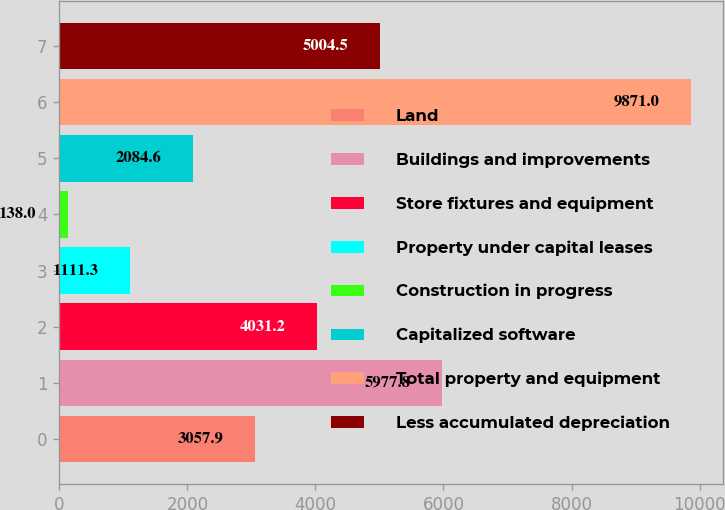Convert chart to OTSL. <chart><loc_0><loc_0><loc_500><loc_500><bar_chart><fcel>Land<fcel>Buildings and improvements<fcel>Store fixtures and equipment<fcel>Property under capital leases<fcel>Construction in progress<fcel>Capitalized software<fcel>Total property and equipment<fcel>Less accumulated depreciation<nl><fcel>3057.9<fcel>5977.8<fcel>4031.2<fcel>1111.3<fcel>138<fcel>2084.6<fcel>9871<fcel>5004.5<nl></chart> 